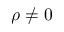Convert formula to latex. <formula><loc_0><loc_0><loc_500><loc_500>\rho \neq 0</formula> 